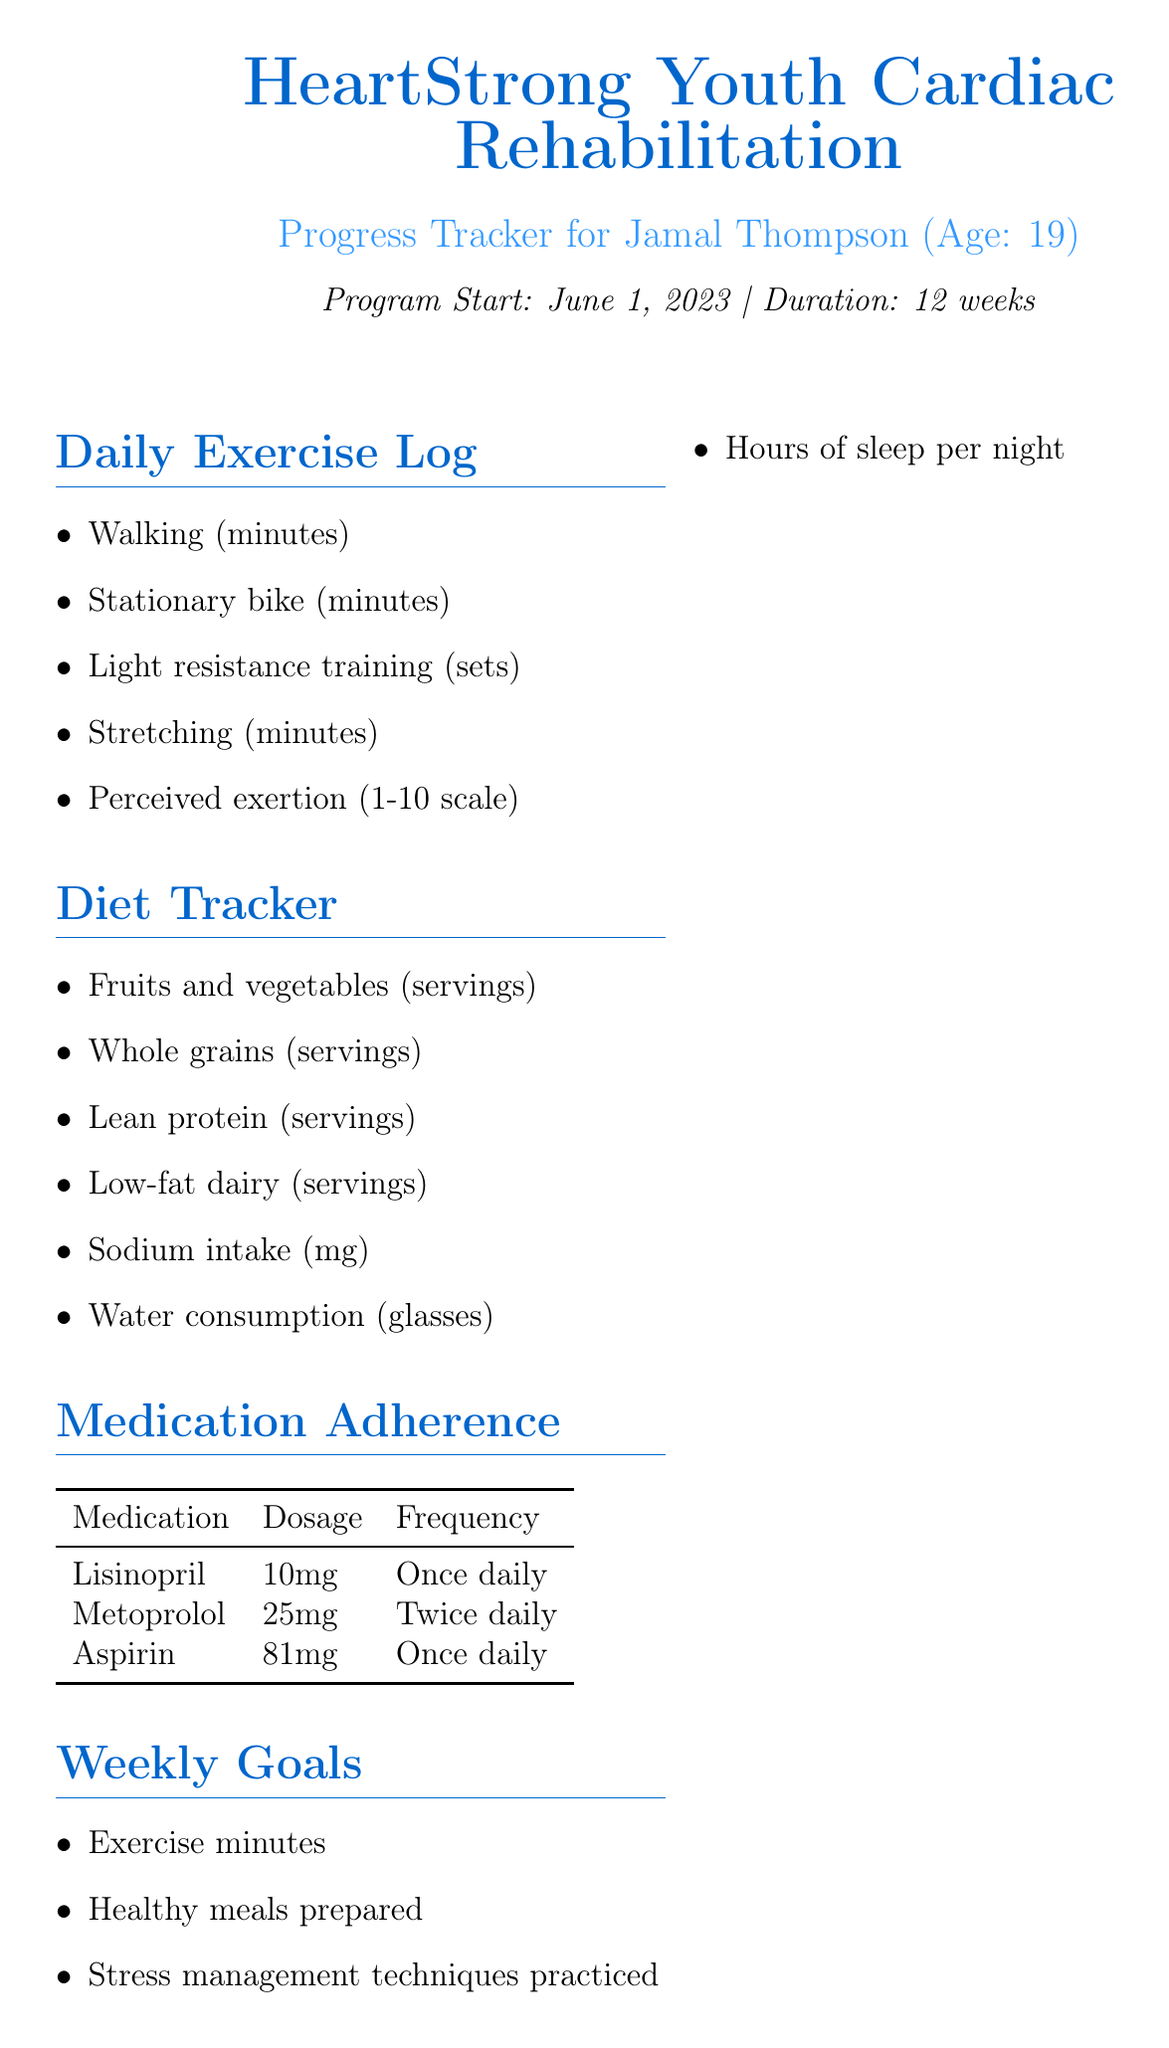What is the program name? The program name is mentioned at the beginning of the document, outlining the title of the cardiac rehabilitation initiative.
Answer: HeartStrong Youth Cardiac Rehabilitation Who is the patient? The patient's name is clearly stated in the progress tracker section of the document.
Answer: Jamal Thompson What is the age of the patient? The age of the patient is specified immediately after the name in the document, providing his relevant demographic information.
Answer: 19 What is the start date of the program? The program start date is given in a specific format for clarity in the document.
Answer: June 1, 2023 How many weeks is the program's duration? The duration of the program is explicitly stated, indicating how long participants are expected to engage in the rehabilitation efforts.
Answer: 12 weeks What medication is taken once daily? The document lists the medications alongside their dosages and frequency, noting which ones are administered at what intervals.
Answer: Lisinopril According to the document, what should be monitored for vital signs? The vital signs to be monitored are outlined in a specific section of the document, indicating key health indicators.
Answer: Resting heart rate, Blood pressure, Weight, Body fat percentage What is one educational topic covered in the program? The educational topics section lists several important concepts pertaining to cardiac health and wellness.
Answer: Understanding your heart condition How many heart-healthy meals should be prepared in a week according to the weekly goals? The weekly goals include a specific quantity of meals to be prepared, highlighting a key aspect of dietary adherence.
Answer: 5 Who is the program coordinator? The program coordinator's name is mentioned in the concluding part of the document, providing contact information for oversight.
Answer: Nurse Sarah Johnson 